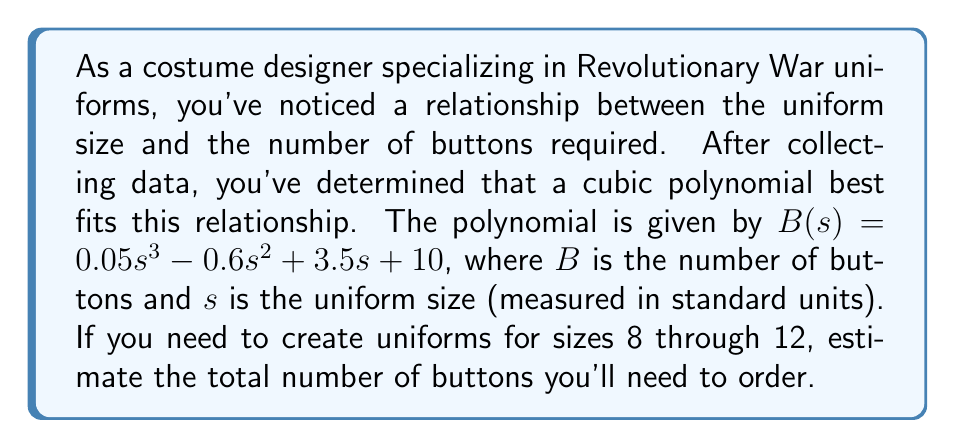Give your solution to this math problem. To solve this problem, we need to follow these steps:

1) The polynomial function for the number of buttons is:
   $B(s) = 0.05s^3 - 0.6s^2 + 3.5s + 10$

2) We need to calculate the number of buttons for sizes 8, 9, 10, 11, and 12.

3) Let's calculate for each size:

   For size 8:
   $B(8) = 0.05(8^3) - 0.6(8^2) + 3.5(8) + 10$
   $= 0.05(512) - 0.6(64) + 28 + 10$
   $= 25.6 - 38.4 + 28 + 10 = 25.2$

   For size 9:
   $B(9) = 0.05(9^3) - 0.6(9^2) + 3.5(9) + 10$
   $= 0.05(729) - 0.6(81) + 31.5 + 10$
   $= 36.45 - 48.6 + 31.5 + 10 = 29.35$

   For size 10:
   $B(10) = 0.05(10^3) - 0.6(10^2) + 3.5(10) + 10$
   $= 0.05(1000) - 0.6(100) + 35 + 10$
   $= 50 - 60 + 35 + 10 = 35$

   For size 11:
   $B(11) = 0.05(11^3) - 0.6(11^2) + 3.5(11) + 10$
   $= 0.05(1331) - 0.6(121) + 38.5 + 10$
   $= 66.55 - 72.6 + 38.5 + 10 = 42.45$

   For size 12:
   $B(12) = 0.05(12^3) - 0.6(12^2) + 3.5(12) + 10$
   $= 0.05(1728) - 0.6(144) + 42 + 10$
   $= 86.4 - 86.4 + 42 + 10 = 52$

4) Now, we need to sum up all these values:
   $25.2 + 29.35 + 35 + 42.45 + 52 = 184$

5) Since we can't have fractional buttons, we should round up to the nearest whole number.
Answer: 185 buttons 